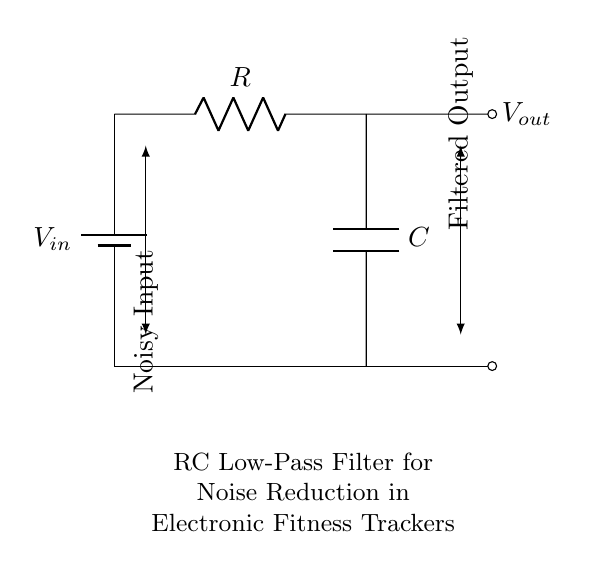What is the input voltage of this circuit? The input voltage is denoted as V in the circuit diagram, which represents the voltage supplied to the circuit.
Answer: V in What component provides noise reduction? The capacitor in the circuit is responsible for filtering out high-frequency noise, allowing only lower frequencies to pass through, which contributes to noise reduction.
Answer: C What type of filter is represented in this circuit? This circuit represents a low-pass filter, which allows low frequencies to pass through while attenuating high frequencies, as indicated by the configuration of the resistor and capacitor.
Answer: Low-pass filter What happens to high-frequency signals in this circuit? High-frequency signals are attenuated or reduced in amplitude as they pass through the RC filter due to the reactive nature of the capacitor. This results in less noise in the output signal.
Answer: Attenuated What is the role of the resistor in this circuit? The resistor limits the current through the circuit and helps set the time constant along with the capacitor, which influences the cutoff frequency of the filter.
Answer: Current limiting What do the arrows in the diagram indicate? The arrows indicate the direction of signal flow, showing the transition from noisy input to filtered output, demonstrating how the circuit processes the incoming signal.
Answer: Signal flow 